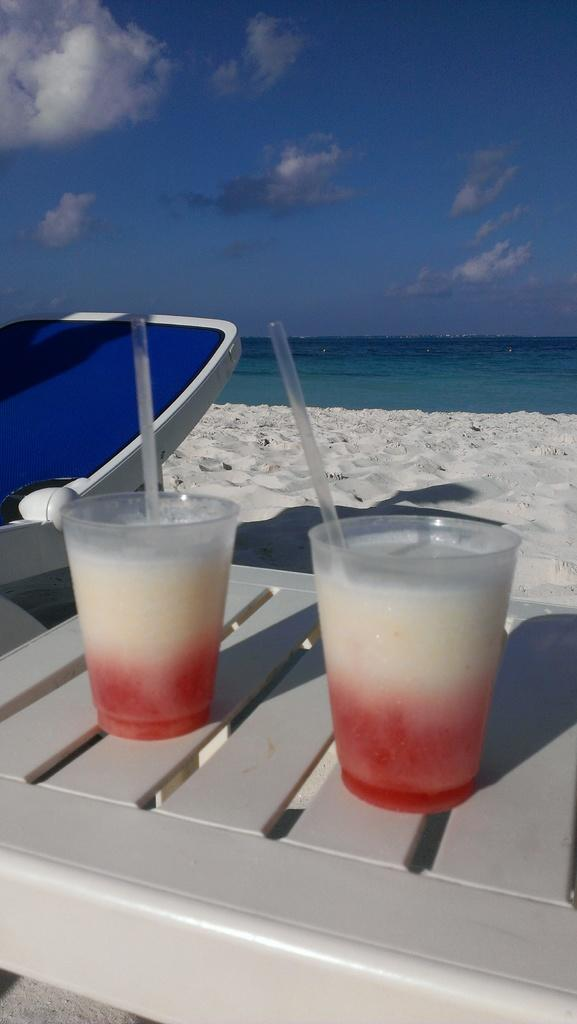What objects are in the image that are used for drinking? There are two glasses with straws in the image. What type of furniture is present in the image? There is a rest chair in the image. What type of terrain is visible in the image? There is sand visible in the image. What natural element is visible in the image? There is water visible in the image. What can be seen in the sky in the image? There are clouds in the sky in the image. What type of lumber is being used to construct the view in the image? There is no mention of lumber or a view in the image; it features two glasses with straws, a rest chair, sand, water, and clouds. 